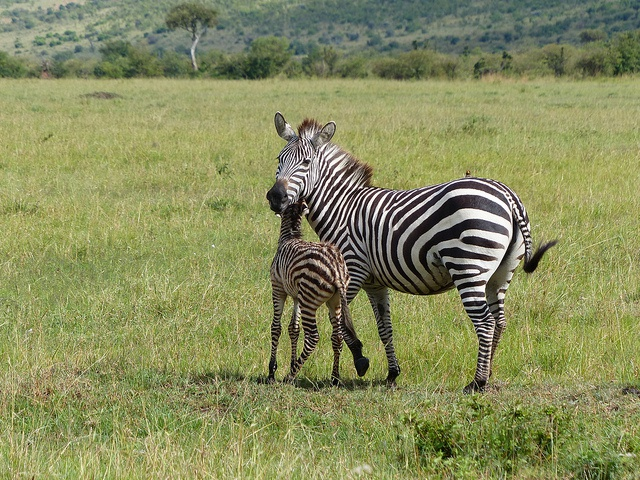Describe the objects in this image and their specific colors. I can see zebra in gray, black, lightgray, and darkgray tones and zebra in gray, black, olive, and darkgreen tones in this image. 